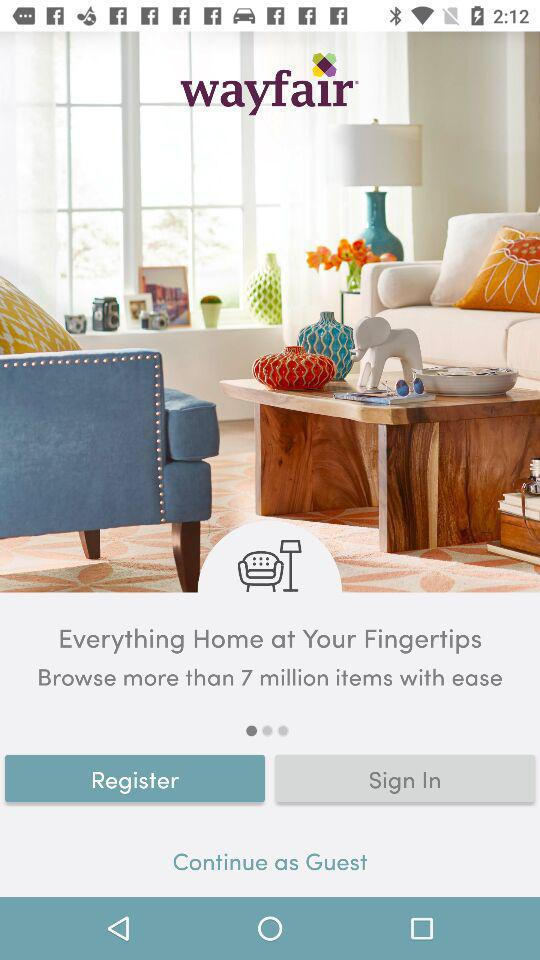What is the app name? The app name is "wayfair". 